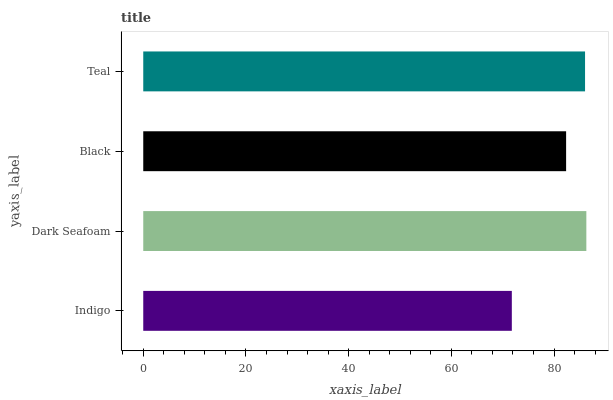Is Indigo the minimum?
Answer yes or no. Yes. Is Dark Seafoam the maximum?
Answer yes or no. Yes. Is Black the minimum?
Answer yes or no. No. Is Black the maximum?
Answer yes or no. No. Is Dark Seafoam greater than Black?
Answer yes or no. Yes. Is Black less than Dark Seafoam?
Answer yes or no. Yes. Is Black greater than Dark Seafoam?
Answer yes or no. No. Is Dark Seafoam less than Black?
Answer yes or no. No. Is Teal the high median?
Answer yes or no. Yes. Is Black the low median?
Answer yes or no. Yes. Is Indigo the high median?
Answer yes or no. No. Is Dark Seafoam the low median?
Answer yes or no. No. 